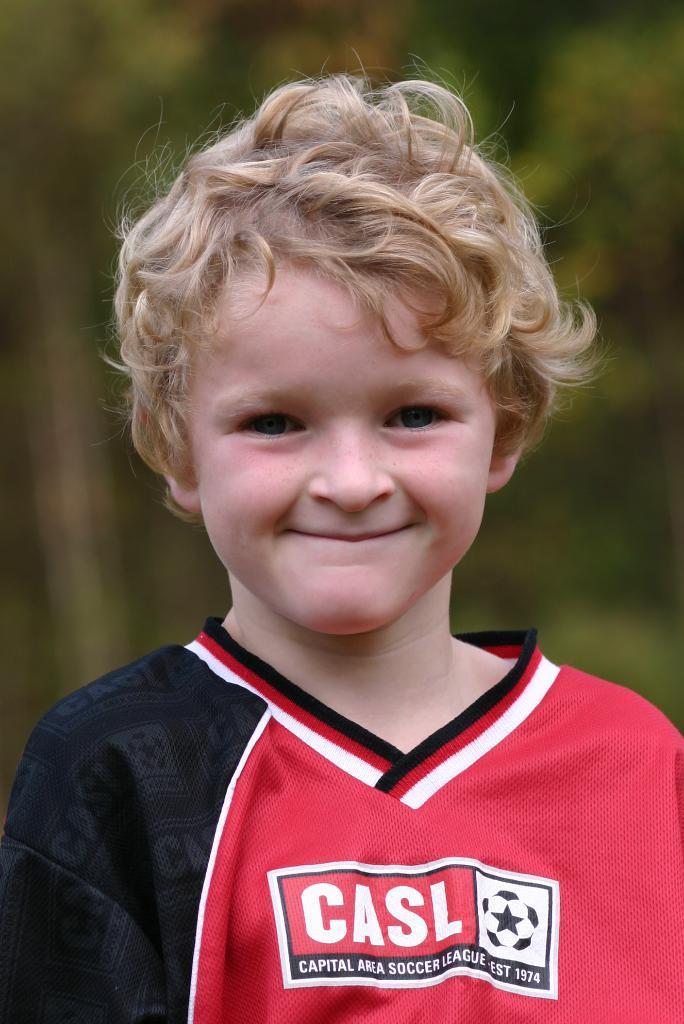In one or two sentences, can you explain what this image depicts? In this image I can see a boy wearing a t-shirt and smiling by looking at the picture. The t-shirt is in red and black colors and on that I can see some text. The background is blurred. 